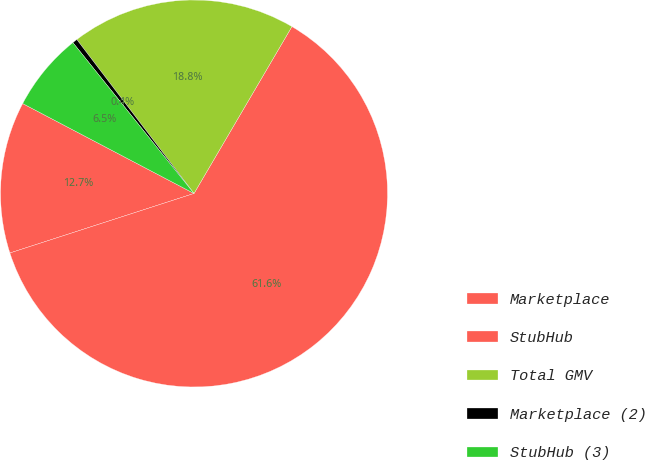<chart> <loc_0><loc_0><loc_500><loc_500><pie_chart><fcel>Marketplace<fcel>StubHub<fcel>Total GMV<fcel>Marketplace (2)<fcel>StubHub (3)<nl><fcel>12.67%<fcel>61.58%<fcel>18.8%<fcel>0.41%<fcel>6.54%<nl></chart> 